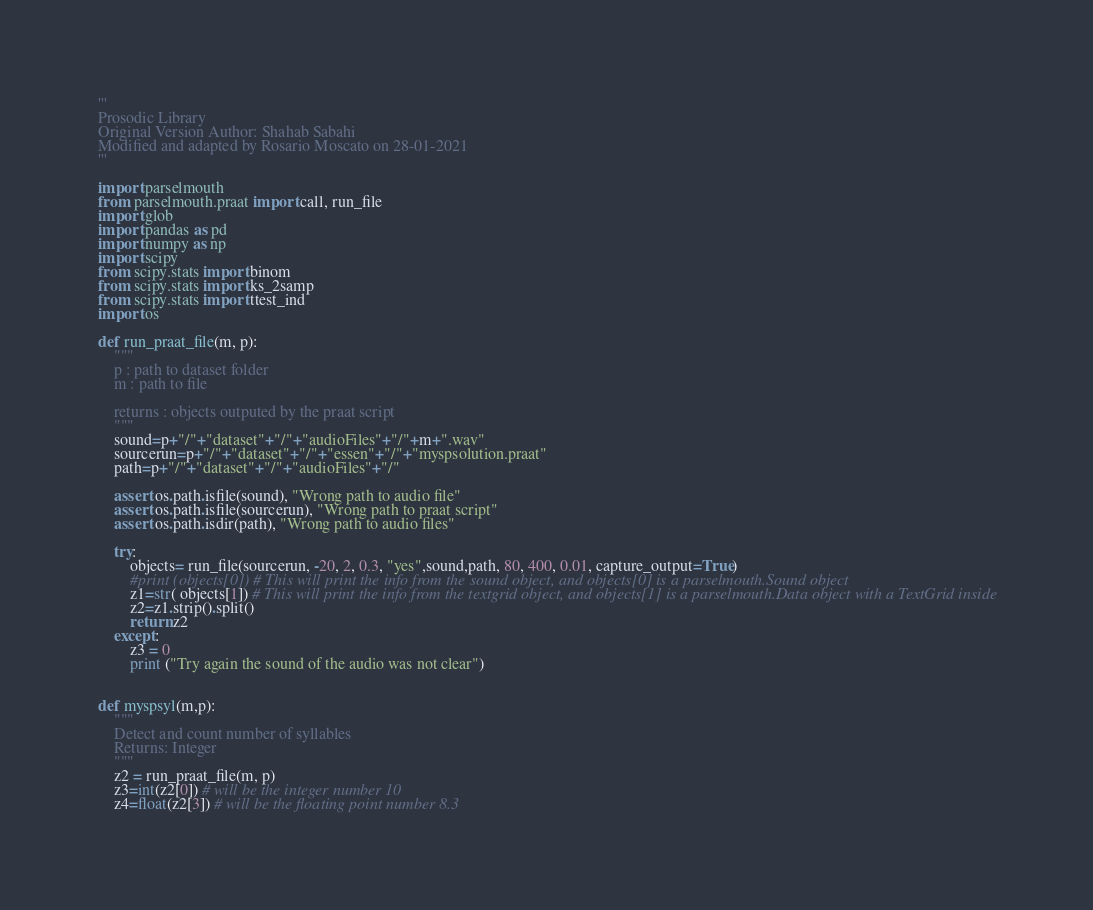Convert code to text. <code><loc_0><loc_0><loc_500><loc_500><_Python_>'''
Prosodic Library
Original Version Author: Shahab Sabahi
Modified and adapted by Rosario Moscato on 28-01-2021
'''

import parselmouth
from parselmouth.praat import call, run_file
import glob
import pandas as pd
import numpy as np
import scipy
from scipy.stats import binom
from scipy.stats import ks_2samp
from scipy.stats import ttest_ind
import os

def run_praat_file(m, p):
    """
    p : path to dataset folder
    m : path to file

    returns : objects outputed by the praat script
    """
    sound=p+"/"+"dataset"+"/"+"audioFiles"+"/"+m+".wav"
    sourcerun=p+"/"+"dataset"+"/"+"essen"+"/"+"myspsolution.praat"
    path=p+"/"+"dataset"+"/"+"audioFiles"+"/"

    assert os.path.isfile(sound), "Wrong path to audio file"
    assert os.path.isfile(sourcerun), "Wrong path to praat script"
    assert os.path.isdir(path), "Wrong path to audio files"

    try:
        objects= run_file(sourcerun, -20, 2, 0.3, "yes",sound,path, 80, 400, 0.01, capture_output=True)
        #print (objects[0]) # This will print the info from the sound object, and objects[0] is a parselmouth.Sound object
        z1=str( objects[1]) # This will print the info from the textgrid object, and objects[1] is a parselmouth.Data object with a TextGrid inside
        z2=z1.strip().split()
        return z2
    except:
        z3 = 0
        print ("Try again the sound of the audio was not clear")


def myspsyl(m,p):
    """
    Detect and count number of syllables
    Returns: Integer
    """
    z2 = run_praat_file(m, p)
    z3=int(z2[0]) # will be the integer number 10
    z4=float(z2[3]) # will be the floating point number 8.3</code> 